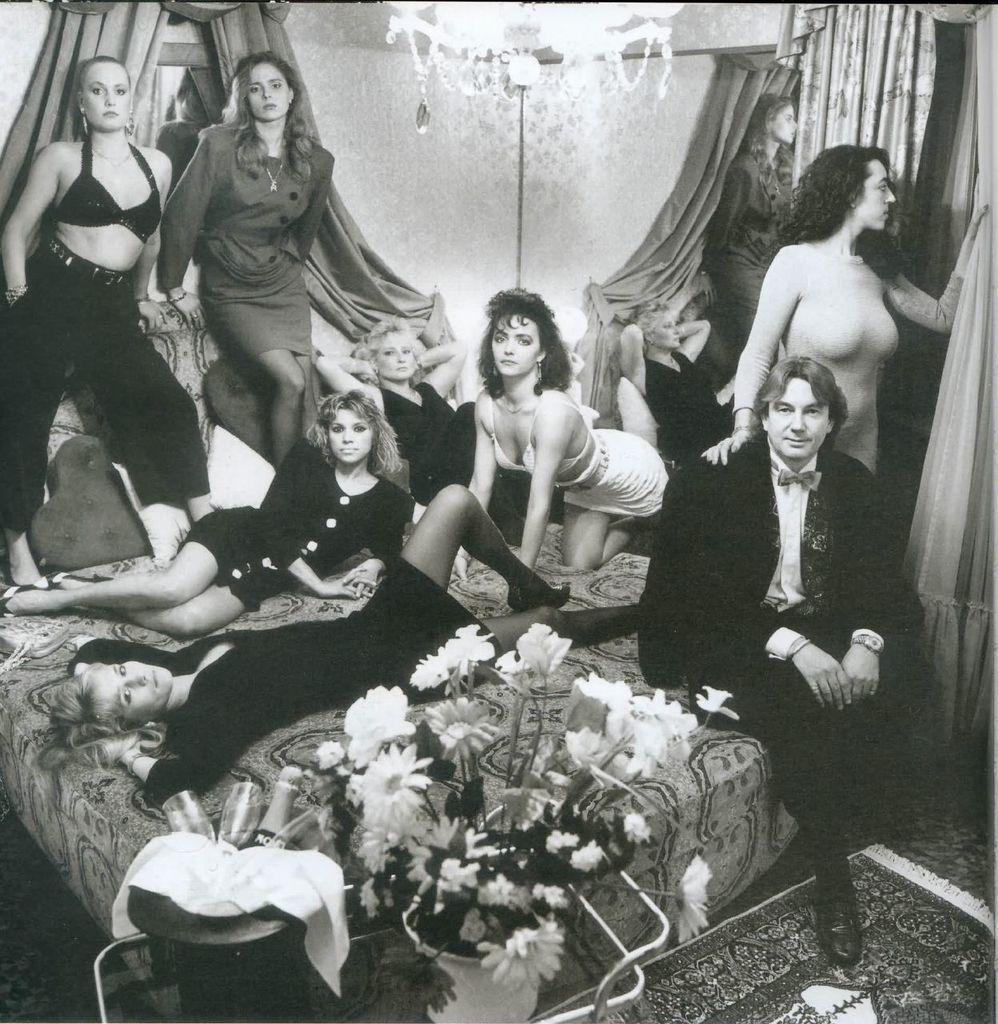How would you summarize this image in a sentence or two? In the image we can see there are women standing and sitting on the bed. There are other women lying on the bed and there is a man sitting on the bed. There are flowers kept in the pot and there is a wine bottle and wine glasses are kept in the bucket. There are curtains on the wall and there is chandelier on the top. The image is in black and white colour. 